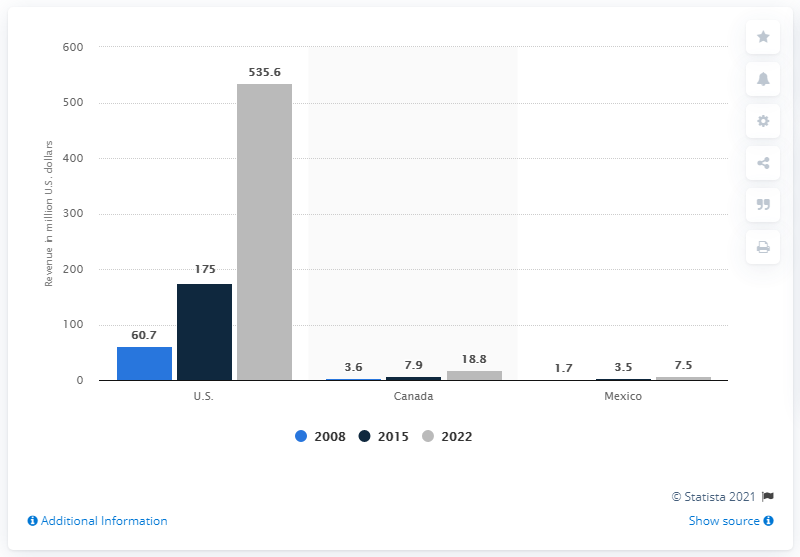Mention a couple of crucial points in this snapshot. In the year 2015, the value of the remote patient monitoring market in the United States was 175 million dollars. In 2015, the estimated value of the remote patient monitoring market in the U.S. was approximately 535.6 million dollars. 